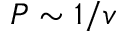<formula> <loc_0><loc_0><loc_500><loc_500>P \sim 1 / v</formula> 